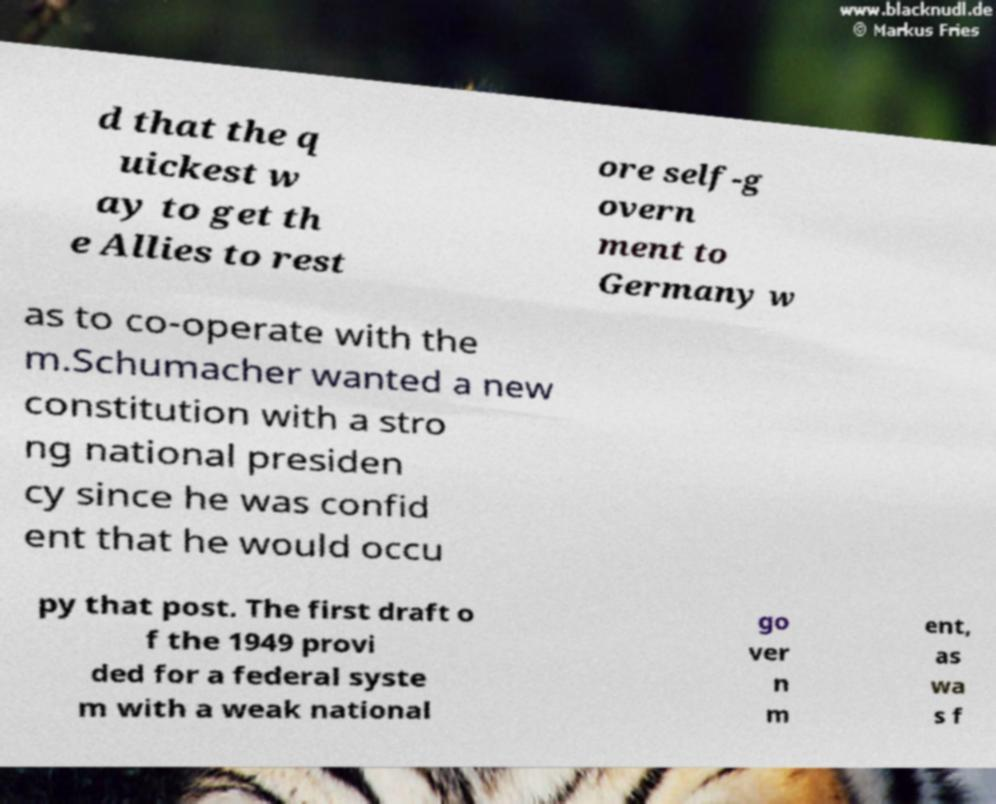What messages or text are displayed in this image? I need them in a readable, typed format. d that the q uickest w ay to get th e Allies to rest ore self-g overn ment to Germany w as to co-operate with the m.Schumacher wanted a new constitution with a stro ng national presiden cy since he was confid ent that he would occu py that post. The first draft o f the 1949 provi ded for a federal syste m with a weak national go ver n m ent, as wa s f 